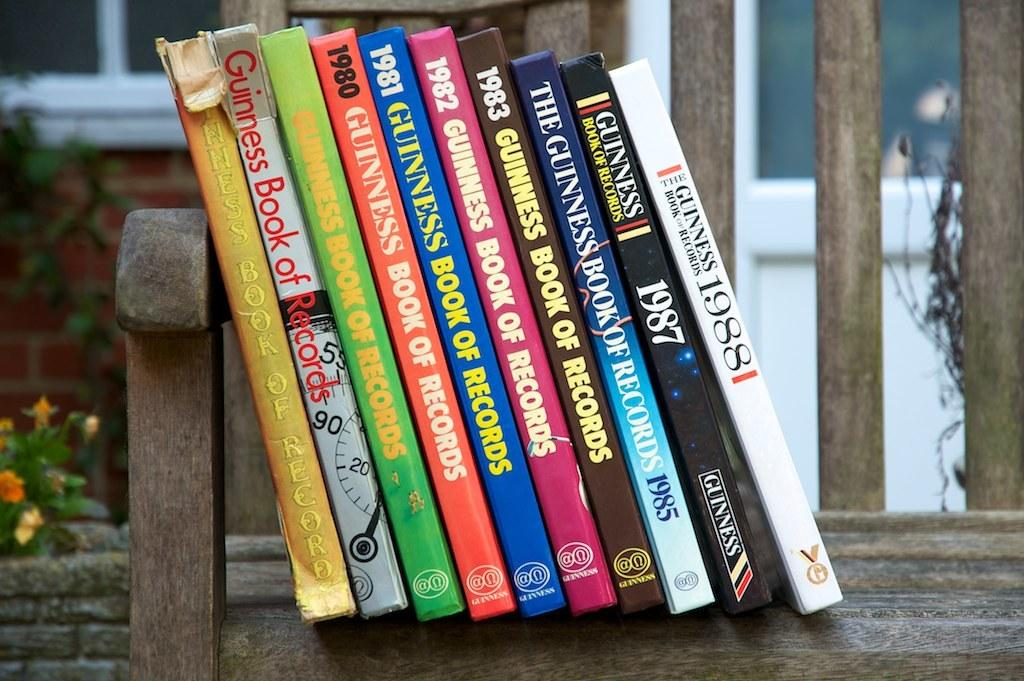<image>
Relay a brief, clear account of the picture shown. The books stacked on the bench are copies of the Guinness Book of Records from the 1980s and 1990s. 